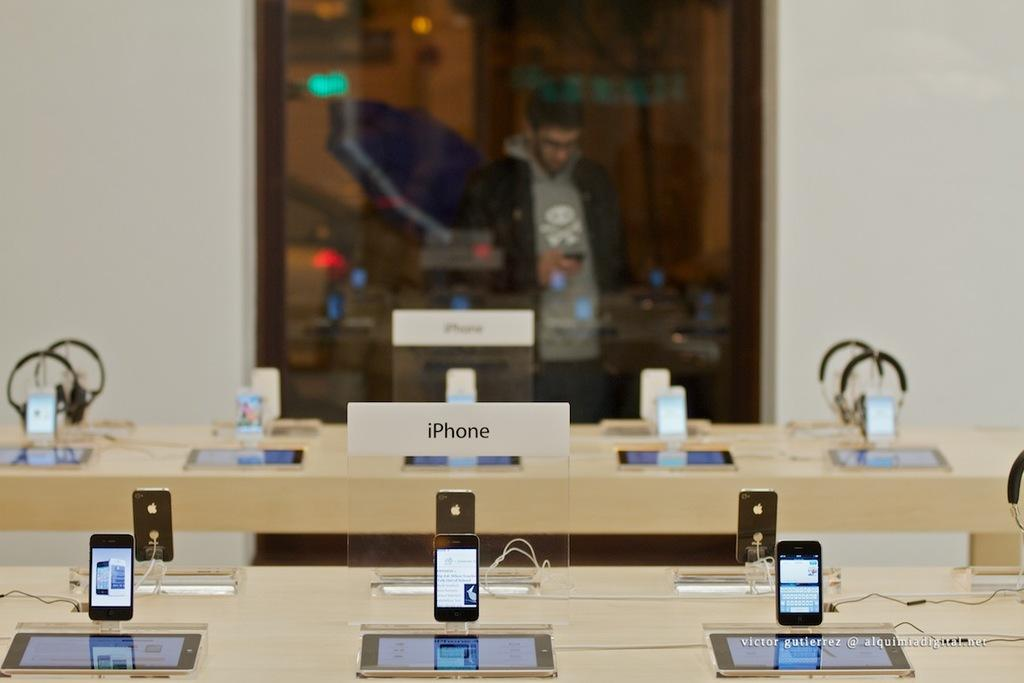<image>
Summarize the visual content of the image. the word iPhone that is among other ones 